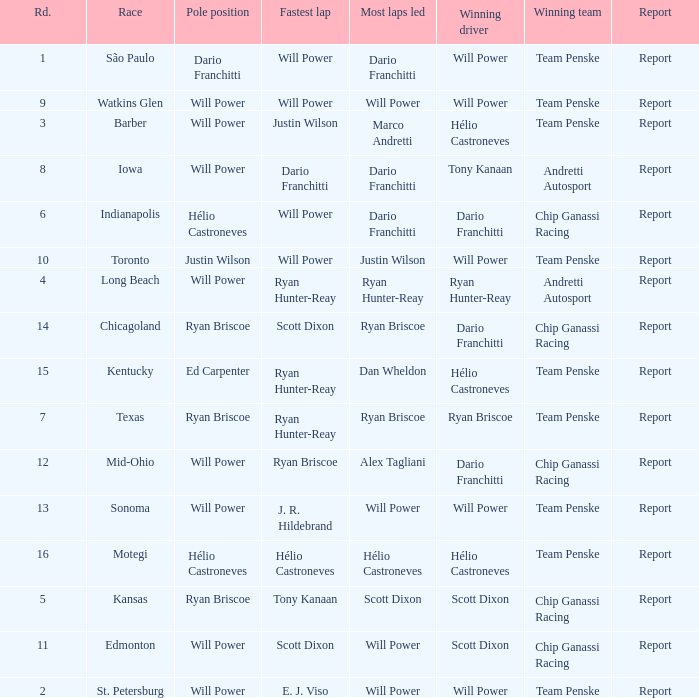Can you give me this table as a dict? {'header': ['Rd.', 'Race', 'Pole position', 'Fastest lap', 'Most laps led', 'Winning driver', 'Winning team', 'Report'], 'rows': [['1', 'São Paulo', 'Dario Franchitti', 'Will Power', 'Dario Franchitti', 'Will Power', 'Team Penske', 'Report'], ['9', 'Watkins Glen', 'Will Power', 'Will Power', 'Will Power', 'Will Power', 'Team Penske', 'Report'], ['3', 'Barber', 'Will Power', 'Justin Wilson', 'Marco Andretti', 'Hélio Castroneves', 'Team Penske', 'Report'], ['8', 'Iowa', 'Will Power', 'Dario Franchitti', 'Dario Franchitti', 'Tony Kanaan', 'Andretti Autosport', 'Report'], ['6', 'Indianapolis', 'Hélio Castroneves', 'Will Power', 'Dario Franchitti', 'Dario Franchitti', 'Chip Ganassi Racing', 'Report'], ['10', 'Toronto', 'Justin Wilson', 'Will Power', 'Justin Wilson', 'Will Power', 'Team Penske', 'Report'], ['4', 'Long Beach', 'Will Power', 'Ryan Hunter-Reay', 'Ryan Hunter-Reay', 'Ryan Hunter-Reay', 'Andretti Autosport', 'Report'], ['14', 'Chicagoland', 'Ryan Briscoe', 'Scott Dixon', 'Ryan Briscoe', 'Dario Franchitti', 'Chip Ganassi Racing', 'Report'], ['15', 'Kentucky', 'Ed Carpenter', 'Ryan Hunter-Reay', 'Dan Wheldon', 'Hélio Castroneves', 'Team Penske', 'Report'], ['7', 'Texas', 'Ryan Briscoe', 'Ryan Hunter-Reay', 'Ryan Briscoe', 'Ryan Briscoe', 'Team Penske', 'Report'], ['12', 'Mid-Ohio', 'Will Power', 'Ryan Briscoe', 'Alex Tagliani', 'Dario Franchitti', 'Chip Ganassi Racing', 'Report'], ['13', 'Sonoma', 'Will Power', 'J. R. Hildebrand', 'Will Power', 'Will Power', 'Team Penske', 'Report'], ['16', 'Motegi', 'Hélio Castroneves', 'Hélio Castroneves', 'Hélio Castroneves', 'Hélio Castroneves', 'Team Penske', 'Report'], ['5', 'Kansas', 'Ryan Briscoe', 'Tony Kanaan', 'Scott Dixon', 'Scott Dixon', 'Chip Ganassi Racing', 'Report'], ['11', 'Edmonton', 'Will Power', 'Scott Dixon', 'Will Power', 'Scott Dixon', 'Chip Ganassi Racing', 'Report'], ['2', 'St. Petersburg', 'Will Power', 'E. J. Viso', 'Will Power', 'Will Power', 'Team Penske', 'Report']]} What is the report for races where Will Power had both pole position and fastest lap? Report. 